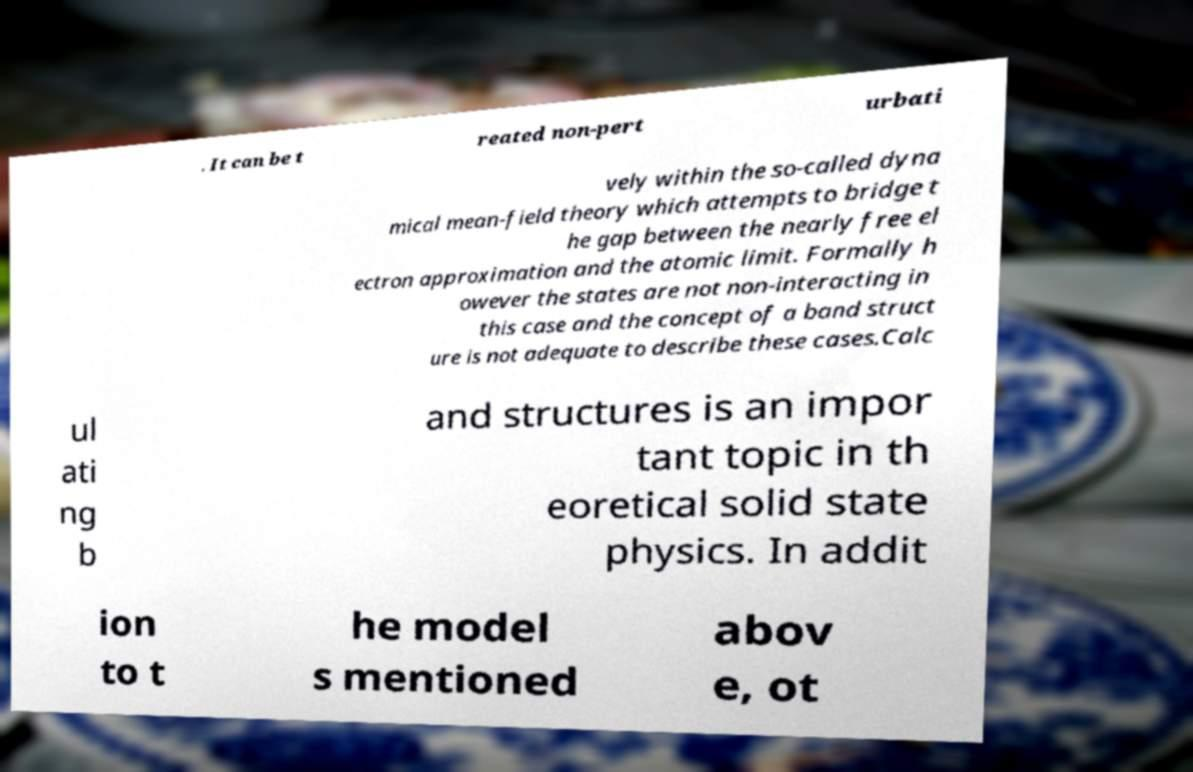Could you extract and type out the text from this image? . It can be t reated non-pert urbati vely within the so-called dyna mical mean-field theory which attempts to bridge t he gap between the nearly free el ectron approximation and the atomic limit. Formally h owever the states are not non-interacting in this case and the concept of a band struct ure is not adequate to describe these cases.Calc ul ati ng b and structures is an impor tant topic in th eoretical solid state physics. In addit ion to t he model s mentioned abov e, ot 